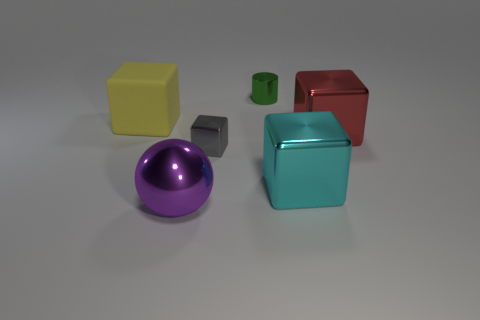Add 4 yellow things. How many objects exist? 10 Subtract all big cubes. How many cubes are left? 1 Subtract all cyan cubes. How many cubes are left? 3 Subtract 3 cubes. How many cubes are left? 1 Add 6 small green metallic cylinders. How many small green metallic cylinders are left? 7 Add 5 green objects. How many green objects exist? 6 Subtract 0 brown cubes. How many objects are left? 6 Subtract all balls. How many objects are left? 5 Subtract all blue blocks. Subtract all brown cylinders. How many blocks are left? 4 Subtract all green rubber objects. Subtract all metal things. How many objects are left? 1 